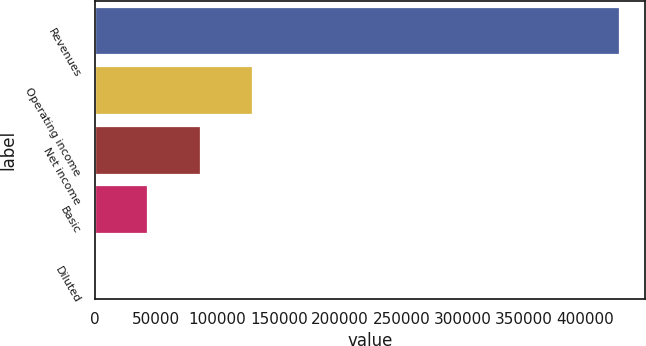<chart> <loc_0><loc_0><loc_500><loc_500><bar_chart><fcel>Revenues<fcel>Operating income<fcel>Net income<fcel>Basic<fcel>Diluted<nl><fcel>427694<fcel>128309<fcel>85539.2<fcel>42769.8<fcel>0.46<nl></chart> 